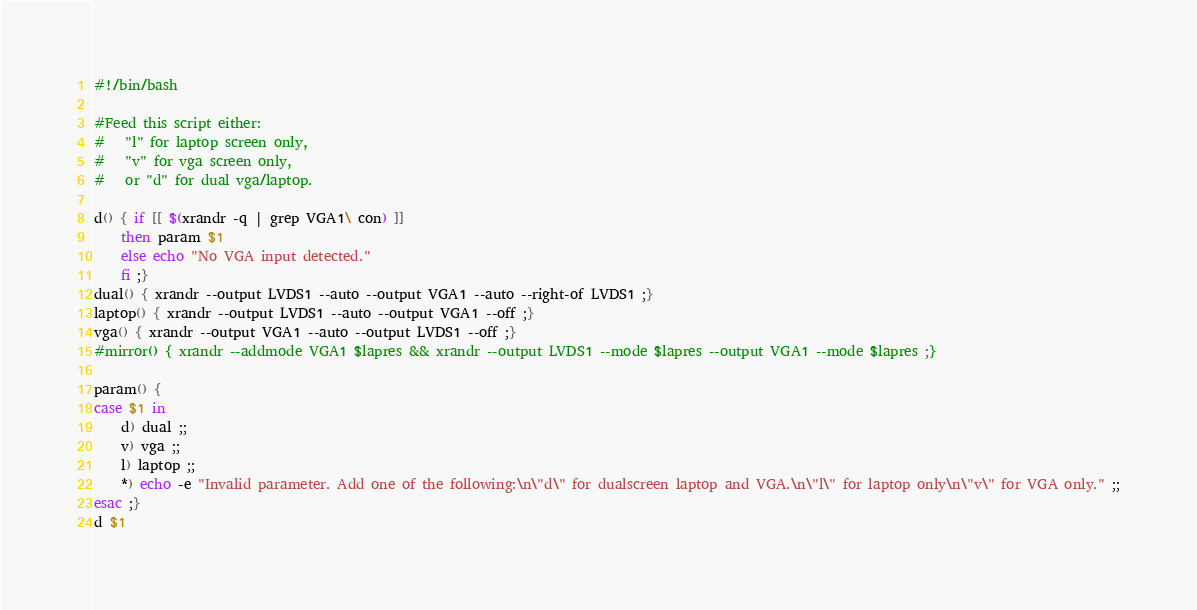<code> <loc_0><loc_0><loc_500><loc_500><_Bash_>#!/bin/bash

#Feed this script either:
#	"l" for laptop screen only,
#	"v" for vga screen only,
#	or "d" for dual vga/laptop.

d() { if [[ $(xrandr -q | grep VGA1\ con) ]]
	then param $1
	else echo "No VGA input detected."
	fi ;}
dual() { xrandr --output LVDS1 --auto --output VGA1 --auto --right-of LVDS1 ;}
laptop() { xrandr --output LVDS1 --auto --output VGA1 --off ;}
vga() { xrandr --output VGA1 --auto --output LVDS1 --off ;}
#mirror() { xrandr --addmode VGA1 $lapres && xrandr --output LVDS1 --mode $lapres --output VGA1 --mode $lapres ;}

param() {
case $1 in
	d) dual ;;
	v) vga ;;
	l) laptop ;;
	*) echo -e "Invalid parameter. Add one of the following:\n\"d\" for dualscreen laptop and VGA.\n\"l\" for laptop only\n\"v\" for VGA only." ;;
esac ;}
d $1
</code> 